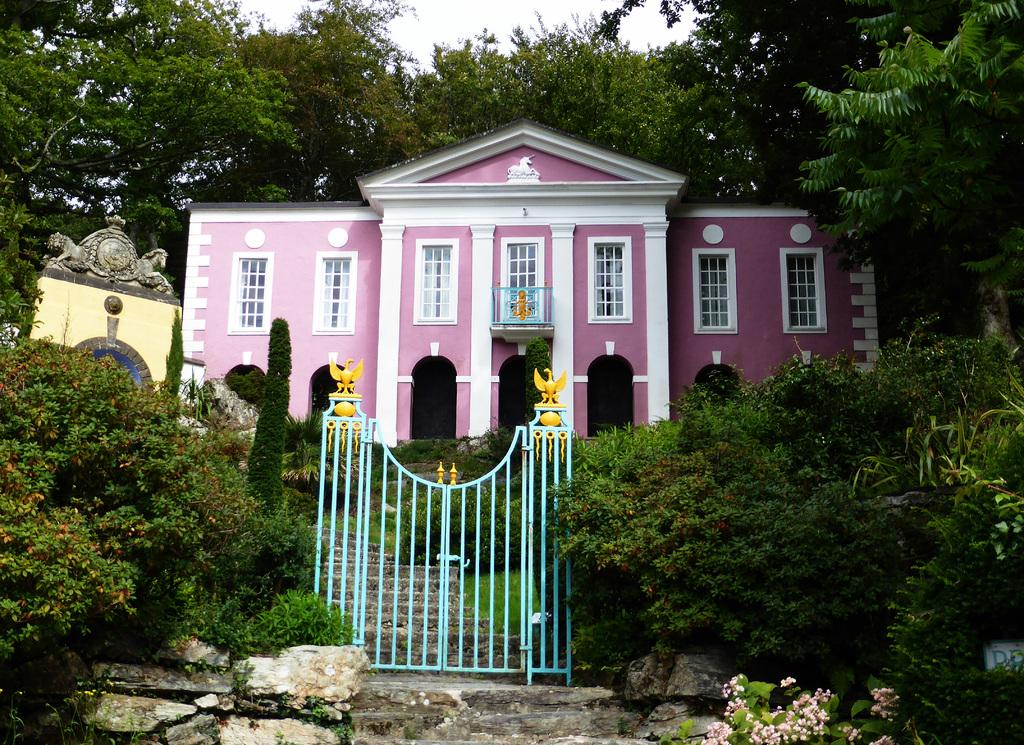What is the main subject in the center of the image? There is a pink color house in the center of the image. What can be seen in the surroundings of the house? There are trees around the area of the image. What is on the left side of the image? There is a decorated wall on the left side of the image. What type of jeans is the person wearing in the image? There is no person wearing jeans present in the image. What is the weather like on the day the image was taken? The provided facts do not mention the weather or the day the image was taken. 